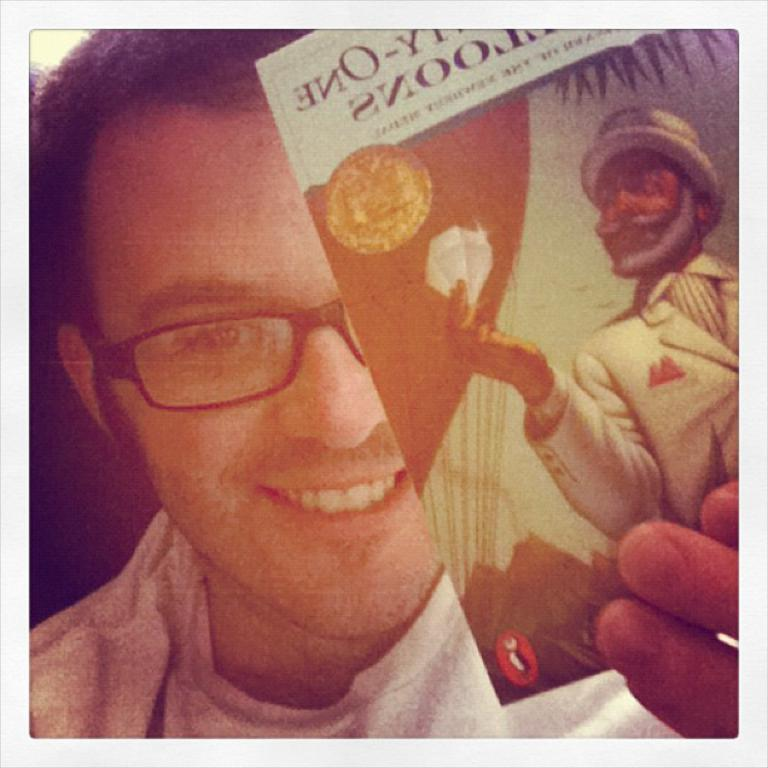Who is present in the image? There is a man in the image. What can be observed about the man's appearance? The man is wearing spectacles and a white color t-shirt. What is the man holding in the image? The man is holding a paper. What type of creature is the man riding in the image? There is no creature present in the image, and the man is not riding anything. 